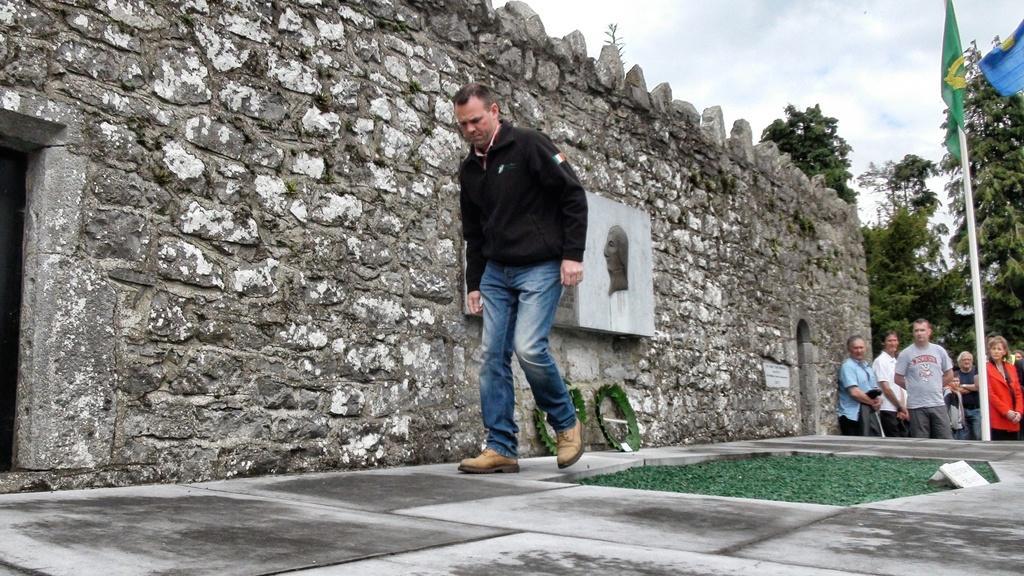Please provide a concise description of this image. In the foreground, I can see a person is walking on the floor and I can see grass. In the background, I can see a stone wall, a group of people are standing, flag poles, trees and the sky. This image is taken, maybe during a day. 